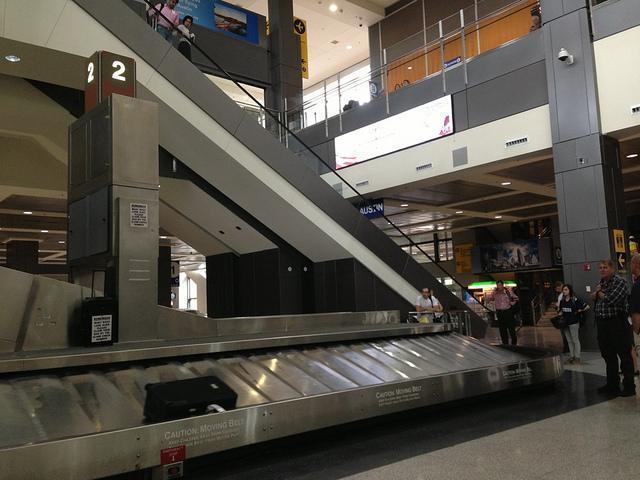What color is the suitcase on the luggage rack underneath the number two?
Choose the right answer from the provided options to respond to the question.
Options: Blue, orange, black, red. Black. 